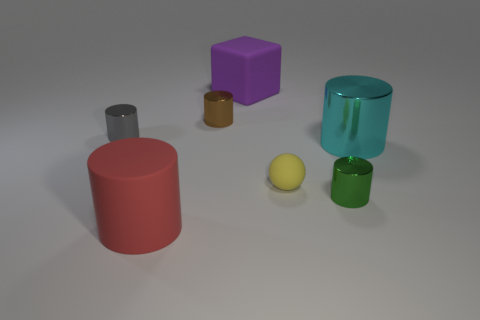Subtract all small metal cylinders. How many cylinders are left? 2 Subtract all cyan cylinders. How many cylinders are left? 4 Add 3 green objects. How many objects exist? 10 Subtract all blue cylinders. Subtract all blue blocks. How many cylinders are left? 5 Subtract all spheres. How many objects are left? 6 Subtract all green cylinders. Subtract all green shiny cylinders. How many objects are left? 5 Add 5 tiny cylinders. How many tiny cylinders are left? 8 Add 5 large cylinders. How many large cylinders exist? 7 Subtract 0 red cubes. How many objects are left? 7 